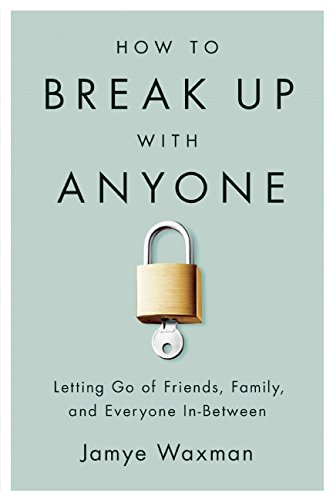Is this a motivational book? Yes, this is a motivational book that aims to empower readers with guidance on managing and resolving complex personal relationships. 